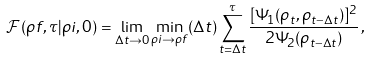<formula> <loc_0><loc_0><loc_500><loc_500>\mathcal { F } ( \rho f , \tau | \rho i , 0 ) = \lim _ { \Delta t \to 0 } \min _ { \rho i \to \rho f } ( \Delta t ) \sum _ { t = \Delta t } ^ { \tau } \frac { [ \Psi _ { 1 } ( \rho _ { t } , \rho _ { t - \Delta t } ) ] ^ { 2 } } { 2 \Psi _ { 2 } ( \rho _ { t - \Delta t } ) } \, ,</formula> 